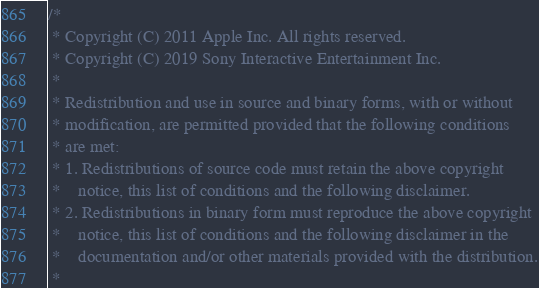Convert code to text. <code><loc_0><loc_0><loc_500><loc_500><_C_>/*
 * Copyright (C) 2011 Apple Inc. All rights reserved.
 * Copyright (C) 2019 Sony Interactive Entertainment Inc.
 *
 * Redistribution and use in source and binary forms, with or without
 * modification, are permitted provided that the following conditions
 * are met:
 * 1. Redistributions of source code must retain the above copyright
 *    notice, this list of conditions and the following disclaimer.
 * 2. Redistributions in binary form must reproduce the above copyright
 *    notice, this list of conditions and the following disclaimer in the
 *    documentation and/or other materials provided with the distribution.
 *</code> 